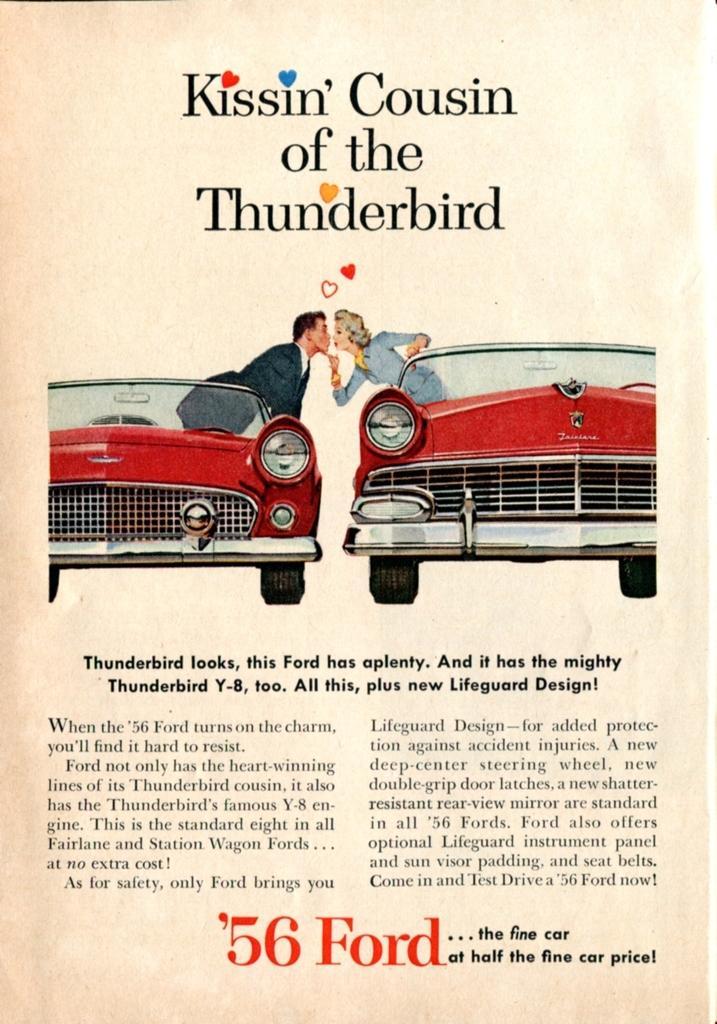Can you describe this image briefly? It is a poster. In this image there are depictions of people standing in the car. There is text on the image. 